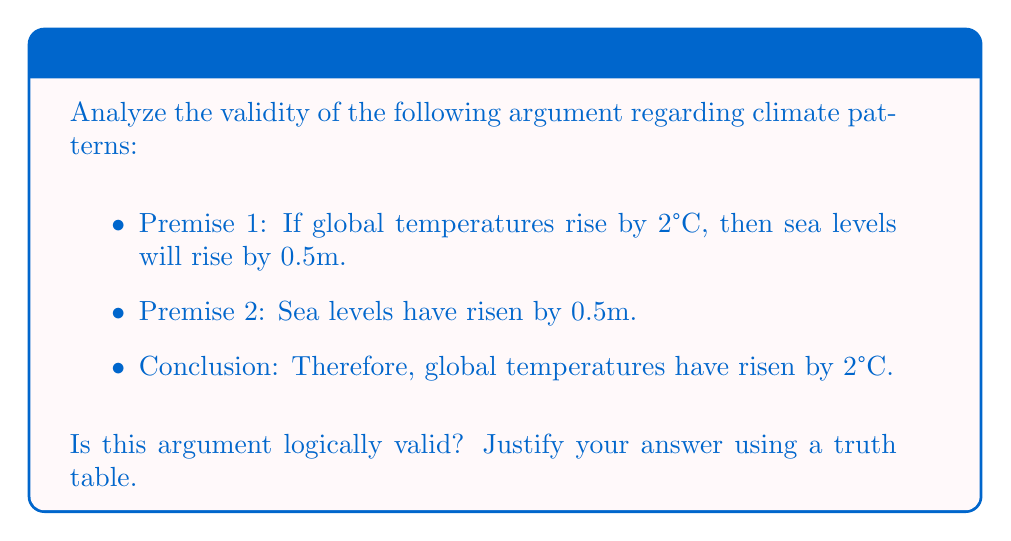Solve this math problem. To analyze the validity of this argument, we need to use propositional logic and construct a truth table. Let's define our propositions:

$p$: Global temperatures rise by 2°C
$q$: Sea levels rise by 0.5m

The argument can be represented as:
$$(p \rightarrow q) \land q \rightarrow p$$

Now, let's construct the truth table:

$$\begin{array}{|c|c|c|c|c|c|}
\hline
p & q & p \rightarrow q & (p \rightarrow q) \land q & (p \rightarrow q) \land q \rightarrow p \\
\hline
T & T & T & T & T \\
T & F & F & F & T \\
F & T & T & T & F \\
F & F & T & F & T \\
\hline
\end{array}$$

Steps:
1. Fill in all possible combinations of T and F for p and q.
2. Evaluate $p \rightarrow q$ for each row.
3. Evaluate $(p \rightarrow q) \land q$ for each row.
4. Evaluate the entire expression $(p \rightarrow q) \land q \rightarrow p$ for each row.

An argument is logically valid if and only if there is no row in the truth table where all premises are true (T) and the conclusion is false (F).

In this case, we can see that in the third row, both premises $(p \rightarrow q)$ and $q$ are true, but the conclusion $p$ is false. This means the argument is not logically valid.

This form of invalid argument is known as the fallacy of affirming the consequent.
Answer: Invalid 